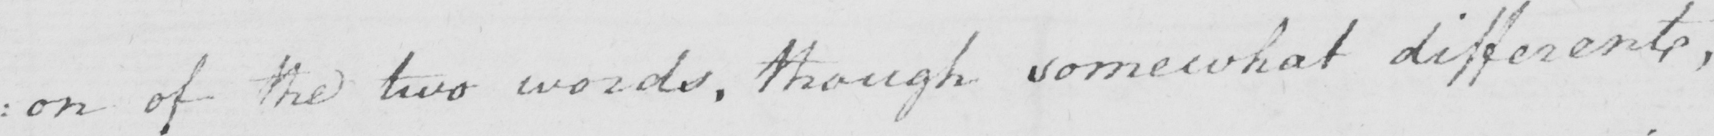Can you tell me what this handwritten text says? : on of the two words , though somewhat different , 